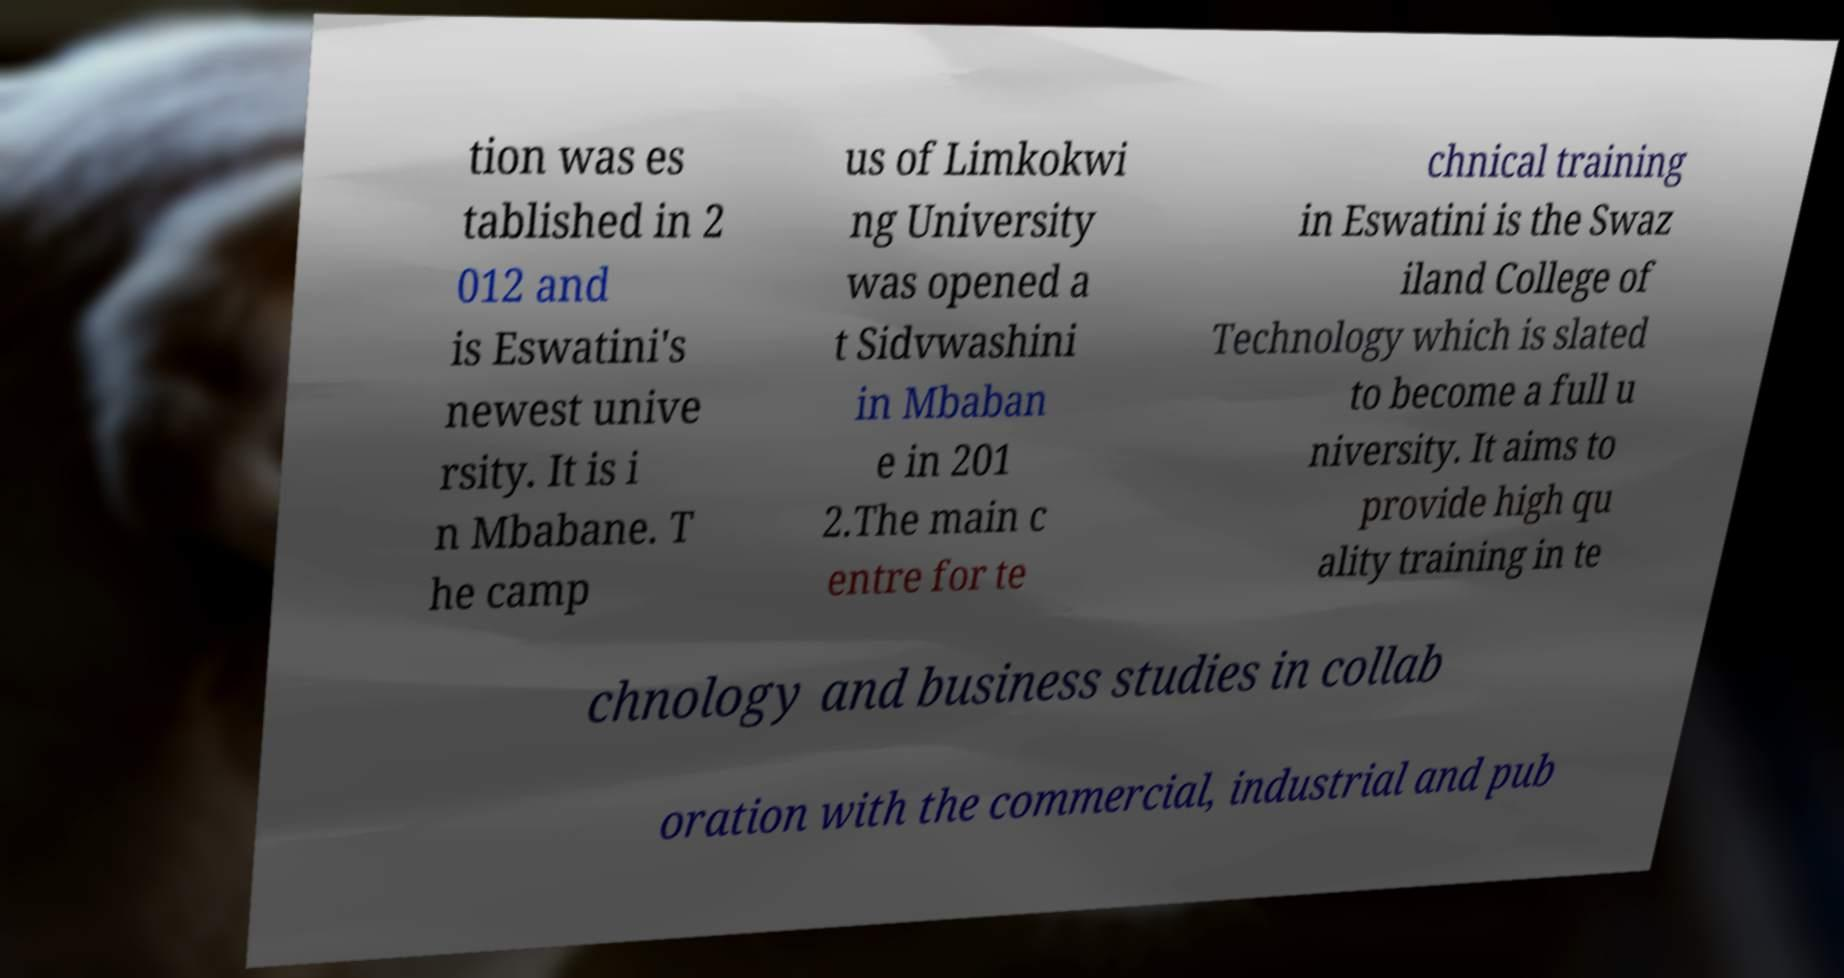There's text embedded in this image that I need extracted. Can you transcribe it verbatim? tion was es tablished in 2 012 and is Eswatini's newest unive rsity. It is i n Mbabane. T he camp us of Limkokwi ng University was opened a t Sidvwashini in Mbaban e in 201 2.The main c entre for te chnical training in Eswatini is the Swaz iland College of Technology which is slated to become a full u niversity. It aims to provide high qu ality training in te chnology and business studies in collab oration with the commercial, industrial and pub 